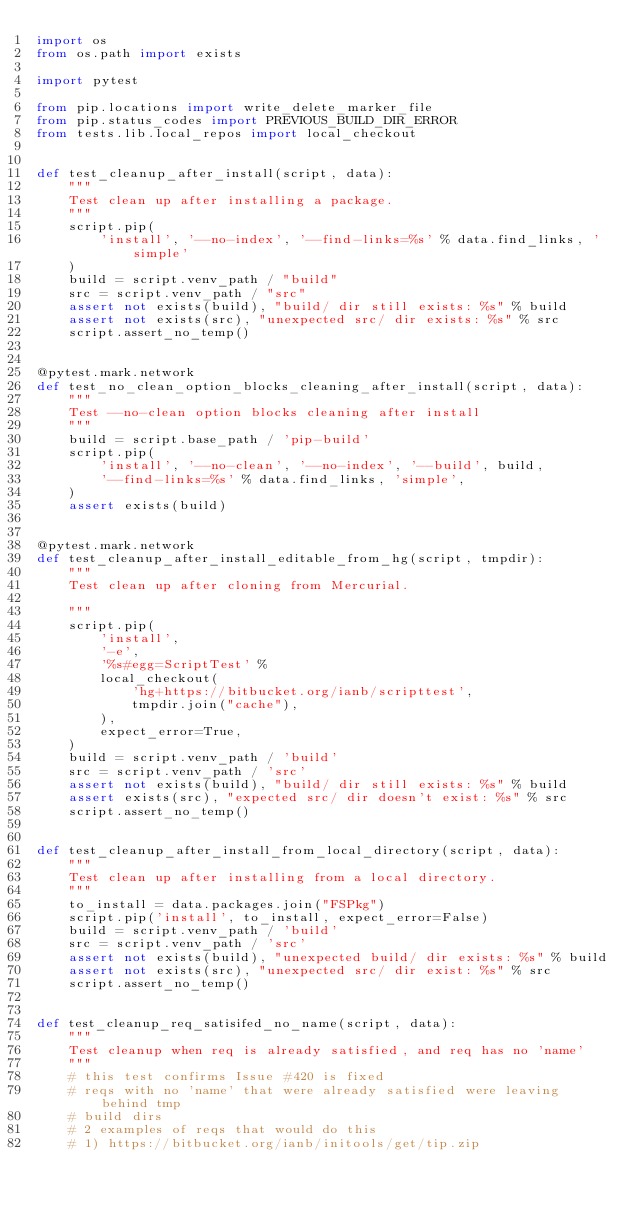Convert code to text. <code><loc_0><loc_0><loc_500><loc_500><_Python_>import os
from os.path import exists

import pytest

from pip.locations import write_delete_marker_file
from pip.status_codes import PREVIOUS_BUILD_DIR_ERROR
from tests.lib.local_repos import local_checkout


def test_cleanup_after_install(script, data):
    """
    Test clean up after installing a package.
    """
    script.pip(
        'install', '--no-index', '--find-links=%s' % data.find_links, 'simple'
    )
    build = script.venv_path / "build"
    src = script.venv_path / "src"
    assert not exists(build), "build/ dir still exists: %s" % build
    assert not exists(src), "unexpected src/ dir exists: %s" % src
    script.assert_no_temp()


@pytest.mark.network
def test_no_clean_option_blocks_cleaning_after_install(script, data):
    """
    Test --no-clean option blocks cleaning after install
    """
    build = script.base_path / 'pip-build'
    script.pip(
        'install', '--no-clean', '--no-index', '--build', build,
        '--find-links=%s' % data.find_links, 'simple',
    )
    assert exists(build)


@pytest.mark.network
def test_cleanup_after_install_editable_from_hg(script, tmpdir):
    """
    Test clean up after cloning from Mercurial.

    """
    script.pip(
        'install',
        '-e',
        '%s#egg=ScriptTest' %
        local_checkout(
            'hg+https://bitbucket.org/ianb/scripttest',
            tmpdir.join("cache"),
        ),
        expect_error=True,
    )
    build = script.venv_path / 'build'
    src = script.venv_path / 'src'
    assert not exists(build), "build/ dir still exists: %s" % build
    assert exists(src), "expected src/ dir doesn't exist: %s" % src
    script.assert_no_temp()


def test_cleanup_after_install_from_local_directory(script, data):
    """
    Test clean up after installing from a local directory.
    """
    to_install = data.packages.join("FSPkg")
    script.pip('install', to_install, expect_error=False)
    build = script.venv_path / 'build'
    src = script.venv_path / 'src'
    assert not exists(build), "unexpected build/ dir exists: %s" % build
    assert not exists(src), "unexpected src/ dir exist: %s" % src
    script.assert_no_temp()


def test_cleanup_req_satisifed_no_name(script, data):
    """
    Test cleanup when req is already satisfied, and req has no 'name'
    """
    # this test confirms Issue #420 is fixed
    # reqs with no 'name' that were already satisfied were leaving behind tmp
    # build dirs
    # 2 examples of reqs that would do this
    # 1) https://bitbucket.org/ianb/initools/get/tip.zip</code> 